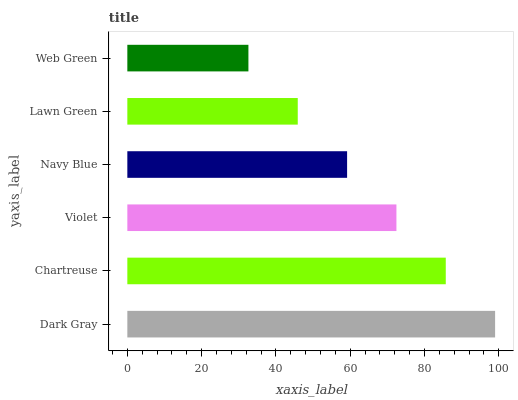Is Web Green the minimum?
Answer yes or no. Yes. Is Dark Gray the maximum?
Answer yes or no. Yes. Is Chartreuse the minimum?
Answer yes or no. No. Is Chartreuse the maximum?
Answer yes or no. No. Is Dark Gray greater than Chartreuse?
Answer yes or no. Yes. Is Chartreuse less than Dark Gray?
Answer yes or no. Yes. Is Chartreuse greater than Dark Gray?
Answer yes or no. No. Is Dark Gray less than Chartreuse?
Answer yes or no. No. Is Violet the high median?
Answer yes or no. Yes. Is Navy Blue the low median?
Answer yes or no. Yes. Is Dark Gray the high median?
Answer yes or no. No. Is Violet the low median?
Answer yes or no. No. 